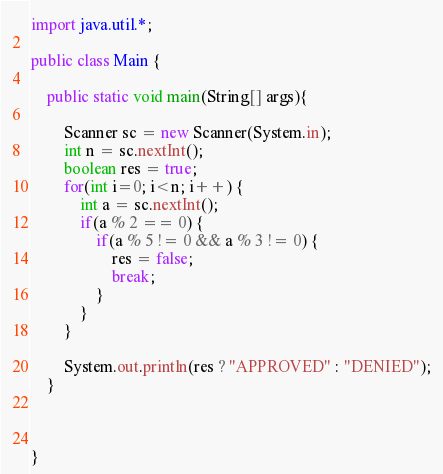Convert code to text. <code><loc_0><loc_0><loc_500><loc_500><_Java_>import java.util.*;

public class Main {

    public static void main(String[] args){

        Scanner sc = new Scanner(System.in);
        int n = sc.nextInt();
        boolean res = true;
        for(int i=0; i<n; i++) {
            int a = sc.nextInt();
            if(a % 2 == 0) {
                if(a % 5 != 0 && a % 3 != 0) {
                    res = false;
                    break;
                }
            }
        }

        System.out.println(res ? "APPROVED" : "DENIED");
    }



}
</code> 